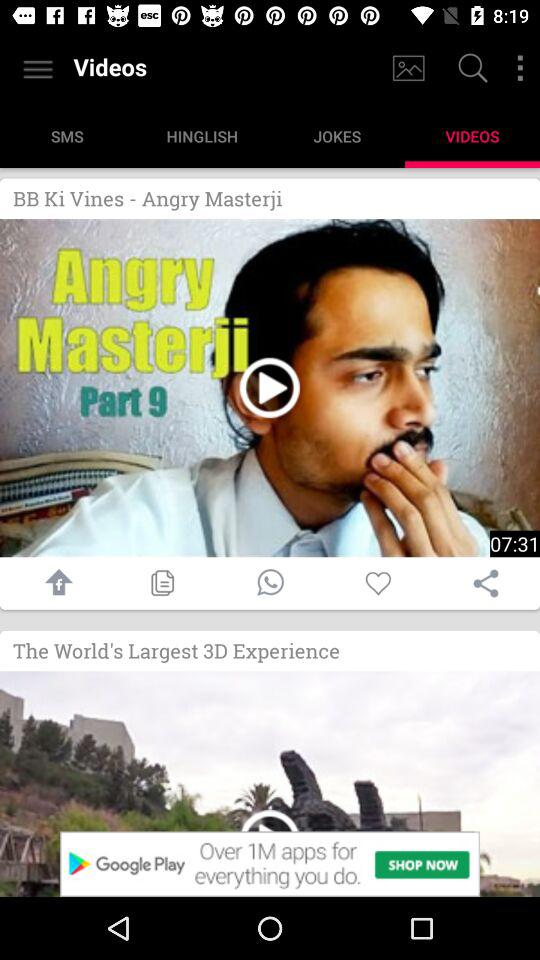Which tab is selected? The selected tab is "Videos". 